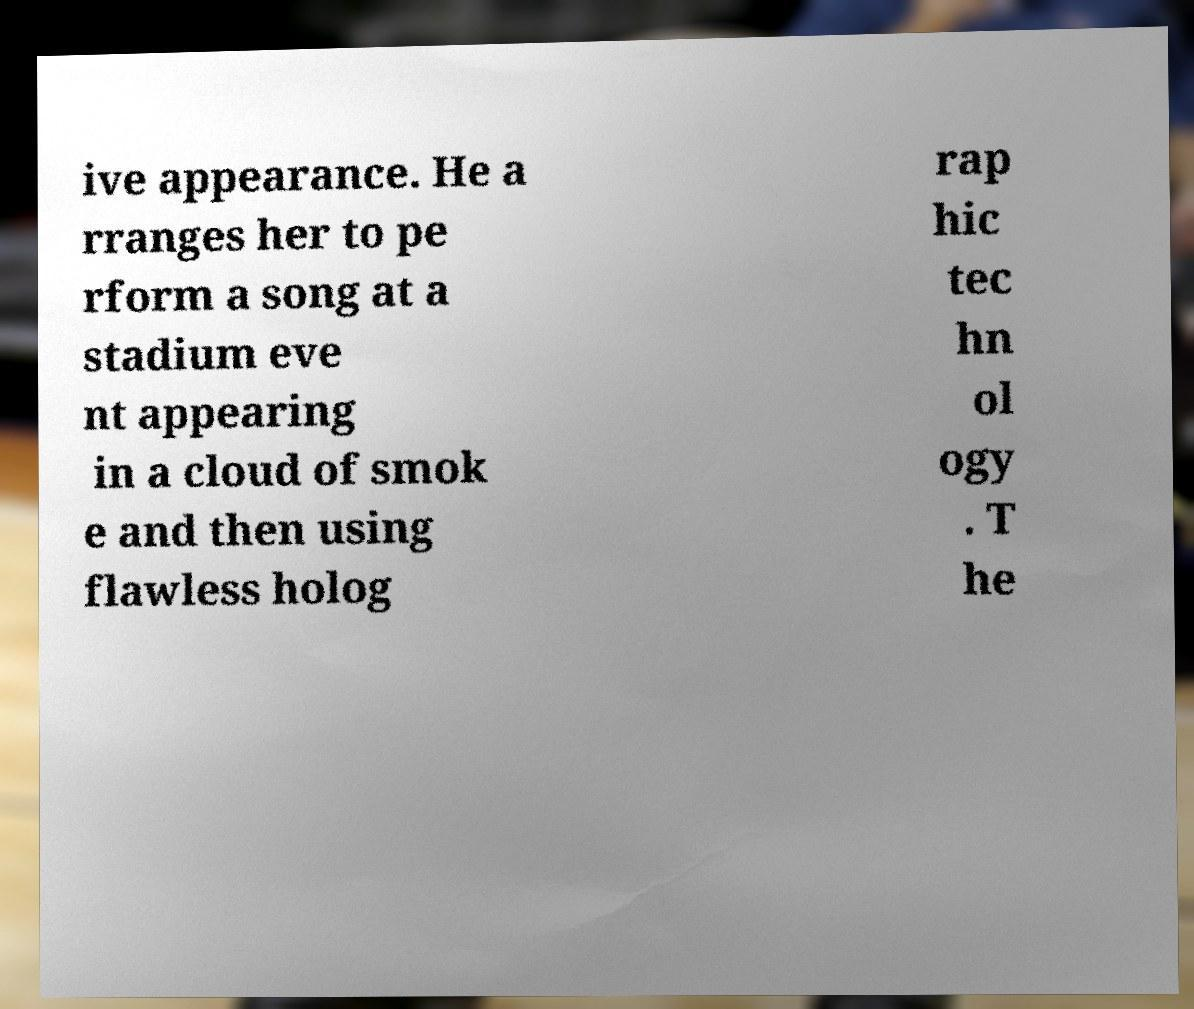Could you assist in decoding the text presented in this image and type it out clearly? ive appearance. He a rranges her to pe rform a song at a stadium eve nt appearing in a cloud of smok e and then using flawless holog rap hic tec hn ol ogy . T he 